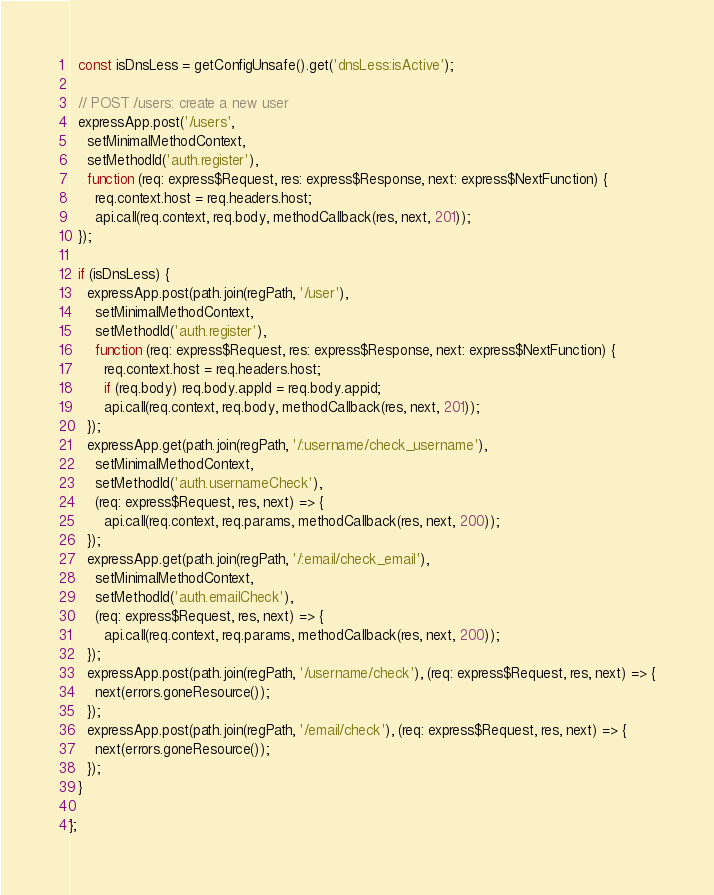Convert code to text. <code><loc_0><loc_0><loc_500><loc_500><_JavaScript_>  const isDnsLess = getConfigUnsafe().get('dnsLess:isActive');

  // POST /users: create a new user
  expressApp.post('/users', 
    setMinimalMethodContext,
    setMethodId('auth.register'),
    function (req: express$Request, res: express$Response, next: express$NextFunction) {
      req.context.host = req.headers.host;
      api.call(req.context, req.body, methodCallback(res, next, 201));
  });
  
  if (isDnsLess) {    
    expressApp.post(path.join(regPath, '/user'), 
      setMinimalMethodContext,
      setMethodId('auth.register'),
      function (req: express$Request, res: express$Response, next: express$NextFunction) {
        req.context.host = req.headers.host;
        if (req.body) req.body.appId = req.body.appid;
        api.call(req.context, req.body, methodCallback(res, next, 201));
    });
    expressApp.get(path.join(regPath, '/:username/check_username'), 
      setMinimalMethodContext,
      setMethodId('auth.usernameCheck'),
      (req: express$Request, res, next) => {
        api.call(req.context, req.params, methodCallback(res, next, 200));
    });
    expressApp.get(path.join(regPath, '/:email/check_email'), 
      setMinimalMethodContext,
      setMethodId('auth.emailCheck'),
      (req: express$Request, res, next) => {
        api.call(req.context, req.params, methodCallback(res, next, 200));
    });
    expressApp.post(path.join(regPath, '/username/check'), (req: express$Request, res, next) => {
      next(errors.goneResource());
    });
    expressApp.post(path.join(regPath, '/email/check'), (req: express$Request, res, next) => {
      next(errors.goneResource());
    });
  }

};</code> 